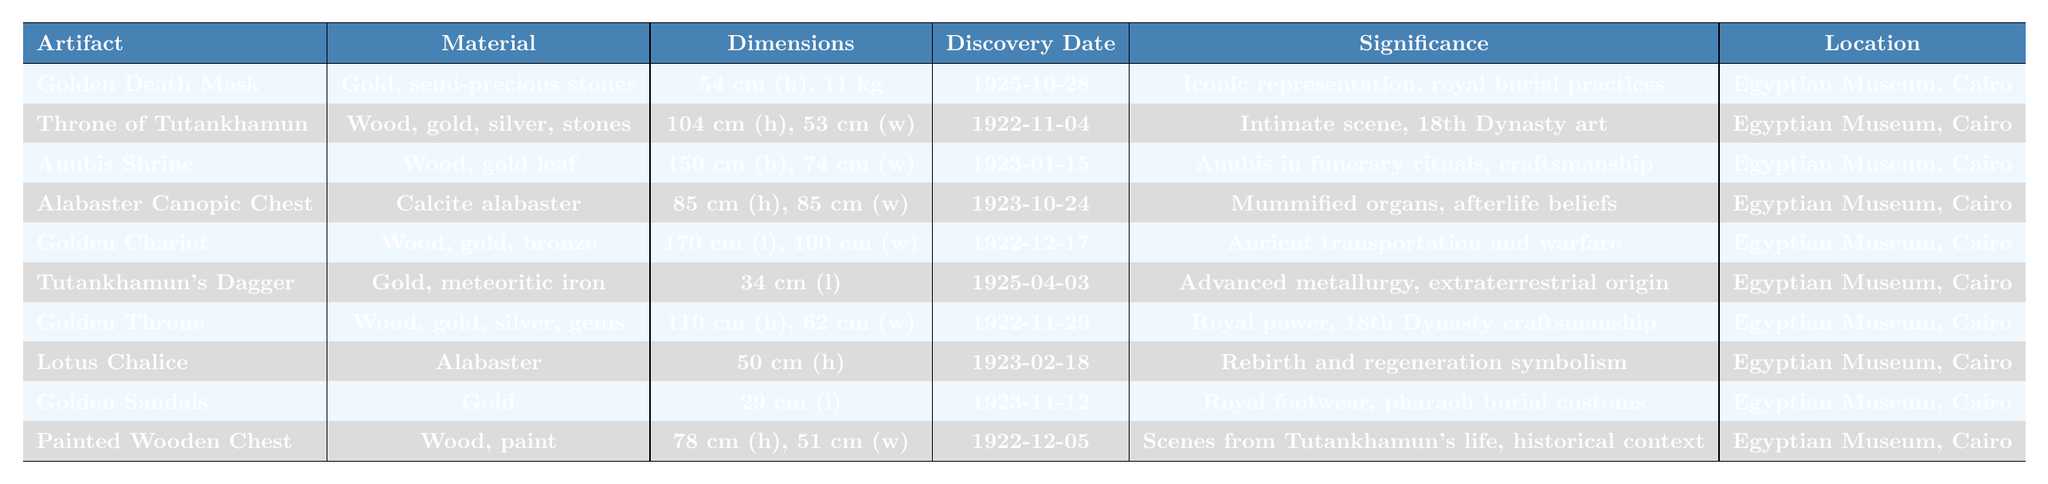What is the material of the Golden Death Mask? The table states that the Golden Death Mask is made of gold and semi-precious stones.
Answer: Gold and semi-precious stones How much does the Throne of Tutankhamun weigh? The table does not provide a weight for the Throne of Tutankhamun, only its dimensions in height and width.
Answer: Not available Which artifact has the longest length? By looking at the dimensions in the table, the Golden Chariot has a length of 170 cm, which is the longest listed.
Answer: Golden Chariot Is the Golden Death Mask located in the Egyptian Museum, Cairo? The table indicates that the current location of the Golden Death Mask is the Egyptian Museum, Cairo.
Answer: Yes What is the significance of the Alabaster Canopic Chest? The table specifies that the Alabaster Canopic Chest contained the king's mummified organs, illustrating Egyptian afterlife beliefs.
Answer: Contained mummified organs, Egyptian afterlife beliefs What is the total height of both the Anubis Shrine and the Golden Throne combined? The height of the Anubis Shrine is 150 cm, and the height of the Golden Throne is 110 cm. Adding these together gives 150 + 110 = 260 cm.
Answer: 260 cm Which artifact was discovered most recently? The Golden Sandals were discovered on November 12, 1923, which is later than the other artifacts listed, making it the most recent discovery.
Answer: Golden Sandals How many artifacts are made of gold? The table lists the Golden Death Mask, Golden Chariot, Tutankhamun's Dagger, Golden Throne, and Golden Sandals, totaling 5 artifacts made of gold.
Answer: 5 What is the significance of the Lotus Chalice? The significance listed in the table for the Lotus Chalice is that it symbolizes rebirth and regeneration in ancient Egyptian beliefs.
Answer: Symbolizes rebirth and regeneration Which artifact showcases advanced metallurgy characteristics? The Tutankhamun's Dagger is indicated as demonstrating advanced metallurgy, possibly of extraterrestrial origin in the table.
Answer: Tutankhamun's Dagger What is the average height of the artifacts that have a height listed? The heights of the listed artifacts are 54 cm (Golden Death Mask), 104 cm (Throne), 150 cm (Anubis Shrine), 85 cm (Canopic Chest), 110 cm (Golden Throne), and 50 cm (Lotus Chalice), summing to 553 cm. There are 6 artifacts, so the average height is 553/6 ≈ 92.17 cm.
Answer: Approximately 92.17 cm Is the Painted Wooden Chest associated with Tutankhamun's life? Yes, the table states that the Painted Wooden Chest contains scenes from Tutankhamun's life, providing historical context.
Answer: Yes What materials are used in the Throne of Tutankhamun? The table indicates that the Throne of Tutankhamun is made of wood, gold, silver, and semi-precious stones.
Answer: Wood, gold, silver, semi-precious stones 